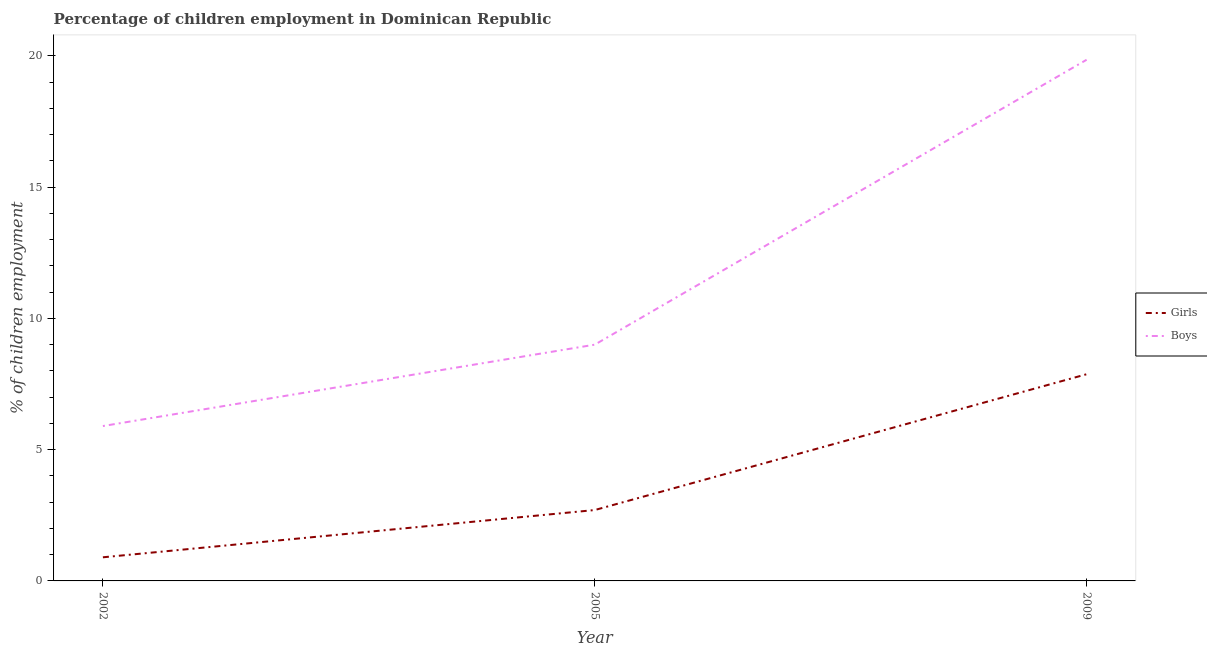How many different coloured lines are there?
Your response must be concise. 2. Does the line corresponding to percentage of employed boys intersect with the line corresponding to percentage of employed girls?
Make the answer very short. No. Is the number of lines equal to the number of legend labels?
Your answer should be compact. Yes. Across all years, what is the maximum percentage of employed girls?
Offer a terse response. 7.87. Across all years, what is the minimum percentage of employed girls?
Make the answer very short. 0.9. In which year was the percentage of employed girls minimum?
Provide a short and direct response. 2002. What is the total percentage of employed boys in the graph?
Provide a succinct answer. 34.75. What is the difference between the percentage of employed boys in 2002 and that in 2005?
Your answer should be compact. -3.1. What is the difference between the percentage of employed girls in 2009 and the percentage of employed boys in 2005?
Your answer should be compact. -1.13. What is the average percentage of employed girls per year?
Make the answer very short. 3.82. In the year 2009, what is the difference between the percentage of employed boys and percentage of employed girls?
Your answer should be compact. 11.98. What is the ratio of the percentage of employed girls in 2005 to that in 2009?
Provide a succinct answer. 0.34. Is the percentage of employed girls in 2005 less than that in 2009?
Your answer should be compact. Yes. What is the difference between the highest and the second highest percentage of employed boys?
Ensure brevity in your answer.  10.85. What is the difference between the highest and the lowest percentage of employed girls?
Provide a short and direct response. 6.97. In how many years, is the percentage of employed girls greater than the average percentage of employed girls taken over all years?
Your answer should be compact. 1. Is the sum of the percentage of employed boys in 2005 and 2009 greater than the maximum percentage of employed girls across all years?
Your response must be concise. Yes. Is the percentage of employed boys strictly greater than the percentage of employed girls over the years?
Your answer should be compact. Yes. What is the difference between two consecutive major ticks on the Y-axis?
Your answer should be compact. 5. Does the graph contain any zero values?
Your response must be concise. No. Does the graph contain grids?
Provide a short and direct response. No. How are the legend labels stacked?
Your answer should be compact. Vertical. What is the title of the graph?
Keep it short and to the point. Percentage of children employment in Dominican Republic. What is the label or title of the X-axis?
Keep it short and to the point. Year. What is the label or title of the Y-axis?
Your response must be concise. % of children employment. What is the % of children employment of Girls in 2002?
Give a very brief answer. 0.9. What is the % of children employment of Boys in 2002?
Provide a succinct answer. 5.9. What is the % of children employment in Girls in 2009?
Make the answer very short. 7.87. What is the % of children employment of Boys in 2009?
Your answer should be very brief. 19.85. Across all years, what is the maximum % of children employment in Girls?
Offer a terse response. 7.87. Across all years, what is the maximum % of children employment in Boys?
Make the answer very short. 19.85. What is the total % of children employment in Girls in the graph?
Provide a succinct answer. 11.47. What is the total % of children employment in Boys in the graph?
Give a very brief answer. 34.75. What is the difference between the % of children employment in Boys in 2002 and that in 2005?
Keep it short and to the point. -3.1. What is the difference between the % of children employment of Girls in 2002 and that in 2009?
Offer a very short reply. -6.97. What is the difference between the % of children employment of Boys in 2002 and that in 2009?
Give a very brief answer. -13.95. What is the difference between the % of children employment of Girls in 2005 and that in 2009?
Keep it short and to the point. -5.17. What is the difference between the % of children employment in Boys in 2005 and that in 2009?
Offer a very short reply. -10.85. What is the difference between the % of children employment in Girls in 2002 and the % of children employment in Boys in 2005?
Provide a short and direct response. -8.1. What is the difference between the % of children employment in Girls in 2002 and the % of children employment in Boys in 2009?
Offer a terse response. -18.95. What is the difference between the % of children employment of Girls in 2005 and the % of children employment of Boys in 2009?
Ensure brevity in your answer.  -17.15. What is the average % of children employment in Girls per year?
Your answer should be very brief. 3.82. What is the average % of children employment of Boys per year?
Provide a succinct answer. 11.58. In the year 2002, what is the difference between the % of children employment in Girls and % of children employment in Boys?
Make the answer very short. -5. In the year 2005, what is the difference between the % of children employment of Girls and % of children employment of Boys?
Keep it short and to the point. -6.3. In the year 2009, what is the difference between the % of children employment in Girls and % of children employment in Boys?
Your answer should be compact. -11.98. What is the ratio of the % of children employment in Boys in 2002 to that in 2005?
Your response must be concise. 0.66. What is the ratio of the % of children employment in Girls in 2002 to that in 2009?
Offer a very short reply. 0.11. What is the ratio of the % of children employment of Boys in 2002 to that in 2009?
Give a very brief answer. 0.3. What is the ratio of the % of children employment of Girls in 2005 to that in 2009?
Make the answer very short. 0.34. What is the ratio of the % of children employment in Boys in 2005 to that in 2009?
Make the answer very short. 0.45. What is the difference between the highest and the second highest % of children employment in Girls?
Your answer should be compact. 5.17. What is the difference between the highest and the second highest % of children employment in Boys?
Offer a very short reply. 10.85. What is the difference between the highest and the lowest % of children employment of Girls?
Your answer should be compact. 6.97. What is the difference between the highest and the lowest % of children employment in Boys?
Make the answer very short. 13.95. 